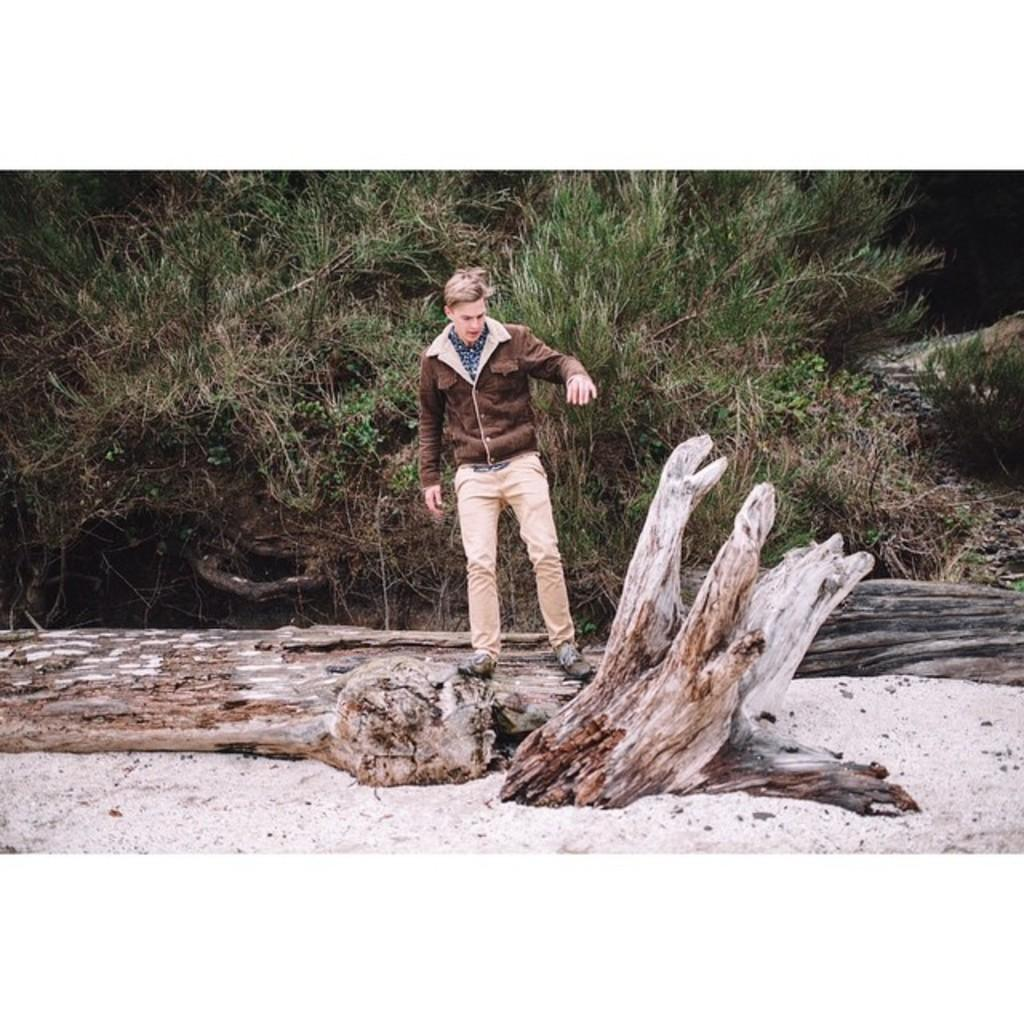What is the person in the image standing on? The person is standing on the wood. What type of vegetation can be seen in the background of the image? There is grass in the background of the image. What object is located at the front of the image? There is a rock at the front of the image. What type of skin can be seen on the person's hands in the image? There is no information about the person's skin in the image, so it cannot be determined. 